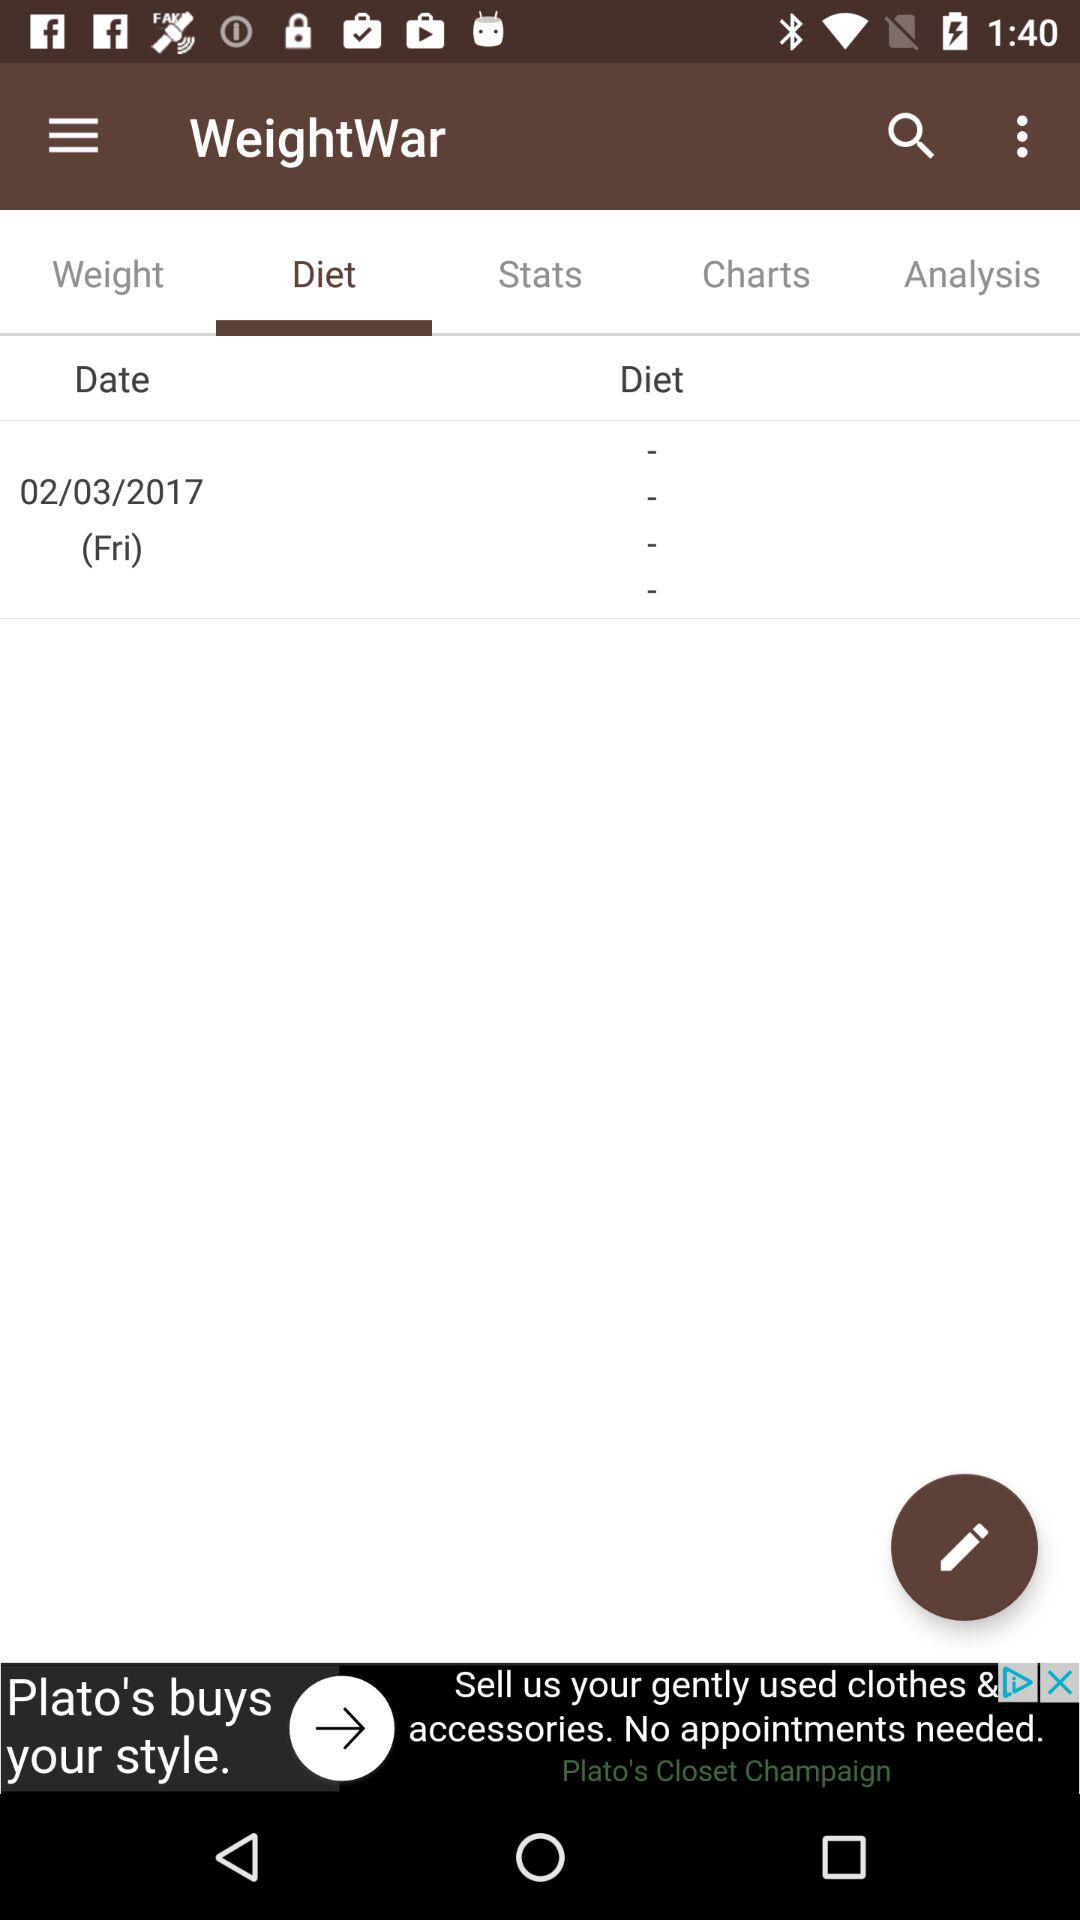Which tab is selected? The selected tab is "Diet". 